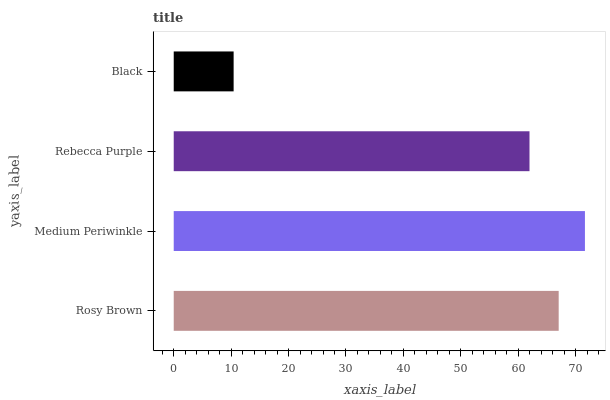Is Black the minimum?
Answer yes or no. Yes. Is Medium Periwinkle the maximum?
Answer yes or no. Yes. Is Rebecca Purple the minimum?
Answer yes or no. No. Is Rebecca Purple the maximum?
Answer yes or no. No. Is Medium Periwinkle greater than Rebecca Purple?
Answer yes or no. Yes. Is Rebecca Purple less than Medium Periwinkle?
Answer yes or no. Yes. Is Rebecca Purple greater than Medium Periwinkle?
Answer yes or no. No. Is Medium Periwinkle less than Rebecca Purple?
Answer yes or no. No. Is Rosy Brown the high median?
Answer yes or no. Yes. Is Rebecca Purple the low median?
Answer yes or no. Yes. Is Medium Periwinkle the high median?
Answer yes or no. No. Is Black the low median?
Answer yes or no. No. 